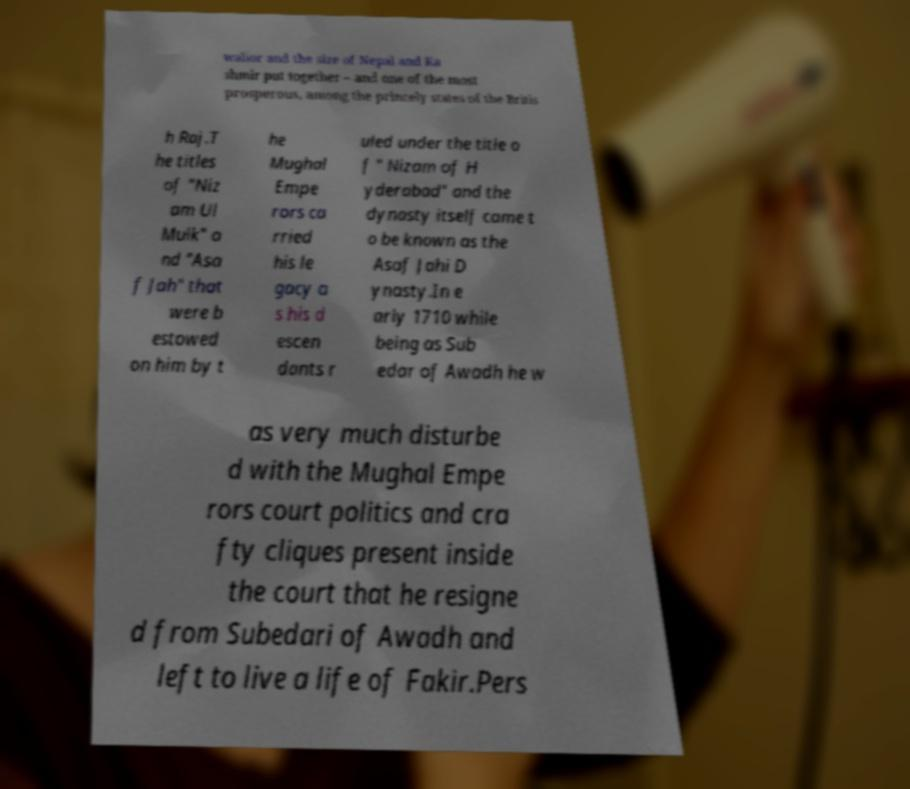Can you read and provide the text displayed in the image?This photo seems to have some interesting text. Can you extract and type it out for me? walior and the size of Nepal and Ka shmir put together – and one of the most prosperous, among the princely states of the Britis h Raj.T he titles of "Niz am Ul Mulk" a nd "Asa f Jah" that were b estowed on him by t he Mughal Empe rors ca rried his le gacy a s his d escen dants r uled under the title o f " Nizam of H yderabad" and the dynasty itself came t o be known as the Asaf Jahi D ynasty.In e arly 1710 while being as Sub edar of Awadh he w as very much disturbe d with the Mughal Empe rors court politics and cra fty cliques present inside the court that he resigne d from Subedari of Awadh and left to live a life of Fakir.Pers 